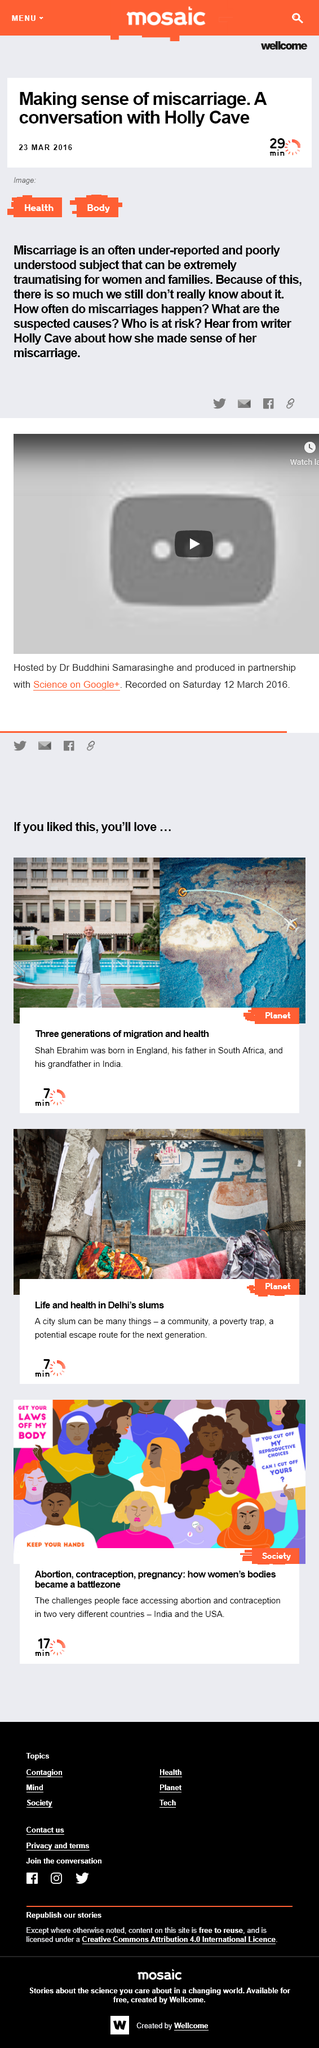Mention a couple of crucial points in this snapshot. The author of this article is unknown, as stated in the text, 'Who was this article written by?' The article will take approximately 29 minutes to read. The article is exploring the theme of miscarriage and the author is trying to make sense of this topic. 